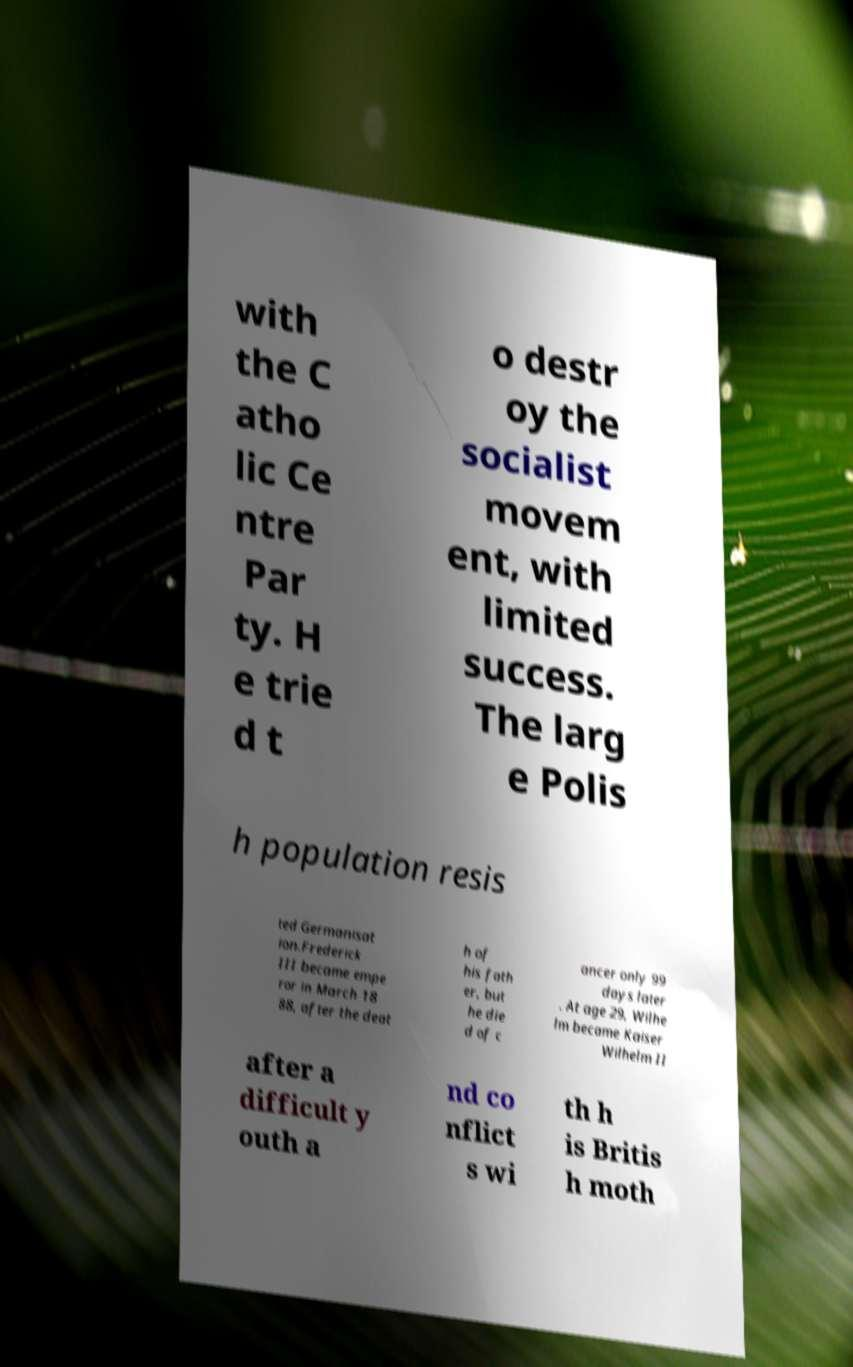Can you read and provide the text displayed in the image?This photo seems to have some interesting text. Can you extract and type it out for me? with the C atho lic Ce ntre Par ty. H e trie d t o destr oy the socialist movem ent, with limited success. The larg e Polis h population resis ted Germanisat ion.Frederick III became empe ror in March 18 88, after the deat h of his fath er, but he die d of c ancer only 99 days later . At age 29, Wilhe lm became Kaiser Wilhelm II after a difficult y outh a nd co nflict s wi th h is Britis h moth 